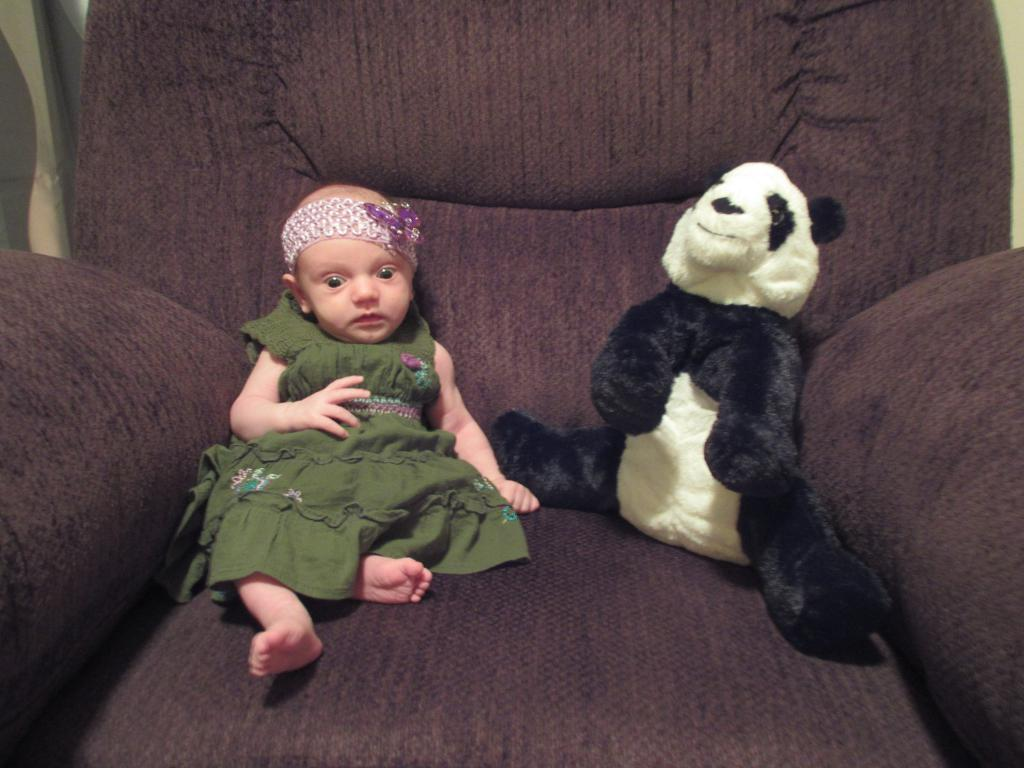What is the main subject of the image? There is a baby in the image. Are there any other subjects in the image? Yes, there is a doll in the image. Where are the baby and the doll located? The baby and the doll are on a brown color sofa. What type of wool is being used to knit a sweater for the baby in the image? There is no wool or sweater being knitted in the image; it only features a baby and a doll on a brown color sofa. 